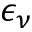<formula> <loc_0><loc_0><loc_500><loc_500>\epsilon _ { \nu }</formula> 